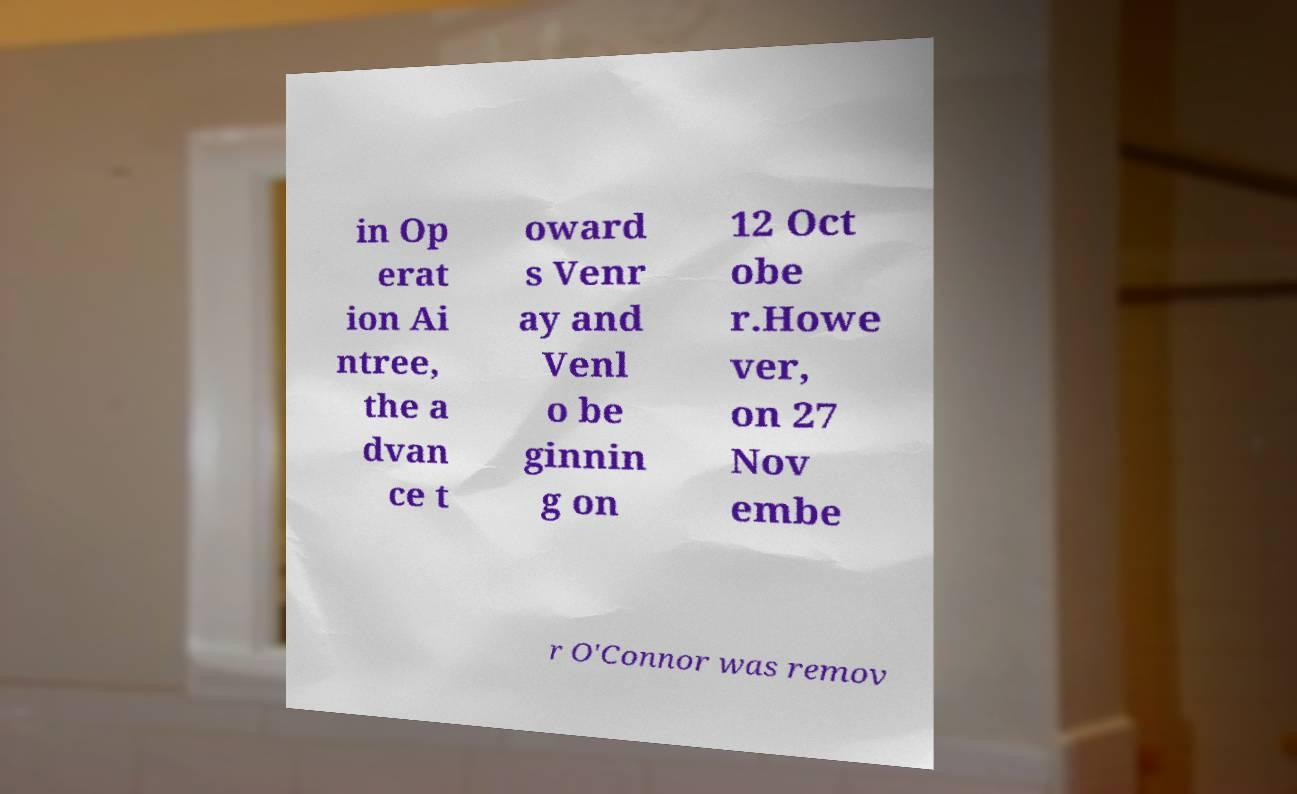Could you assist in decoding the text presented in this image and type it out clearly? in Op erat ion Ai ntree, the a dvan ce t oward s Venr ay and Venl o be ginnin g on 12 Oct obe r.Howe ver, on 27 Nov embe r O'Connor was remov 